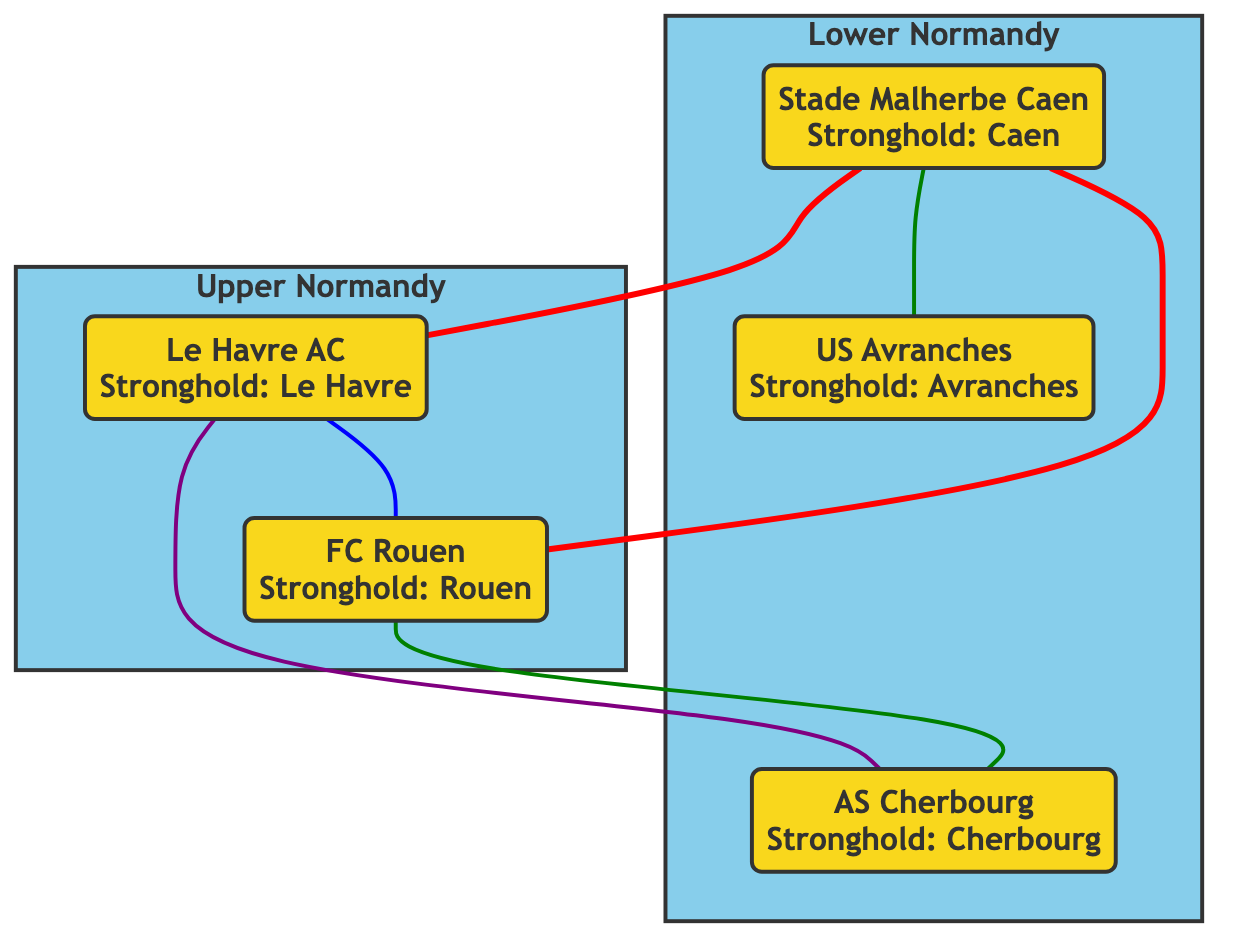What's the stronghold of Stade Malherbe Caen? The diagram shows that Stade Malherbe Caen has its stronghold located in Caen.
Answer: Caen How many football clubs are located in Lower Normandy? Upon examining the Lower Normandy section in the diagram, there are a total of three clubs: Stade Malherbe Caen, US Avranches, and AS Cherbourg.
Answer: 3 Which club is linked to Avranches? The diagram indicates that US Avranches is linked to Stade Malherbe Caen with a rivalry connection.
Answer: Stade Malherbe Caen What color represents the rivalry links in the diagram? The rivalry links between clubs are represented in red, as seen with the thick red lines connecting the clubs.
Answer: Red Which club has a rivalry with both Le Havre and Rouen? By analyzing the connections, it is clear that Stade Malherbe Caen has rivalries with both Le Havre and Rouen, making it the club with connections to both.
Answer: Stade Malherbe Caen How many clubs are connected to FC Rouen? The diagram shows that FC Rouen has three connections: one to Le Havre, one to Stade Malherbe Caen, and one to AS Cherbourg, totaling three connected clubs.
Answer: 3 Which region is represented by the club Cherbourg? The diagram indicates that AS Cherbourg is represented in Lower Normandy, which is the region listed next to the club.
Answer: Lower Normandy What type of relationship is shown between Caen and Cherbourg? The diagram indicates a rivalry relationship between Stade Malherbe Caen and AS Cherbourg, illustrated with a connecting line.
Answer: Rivalry 